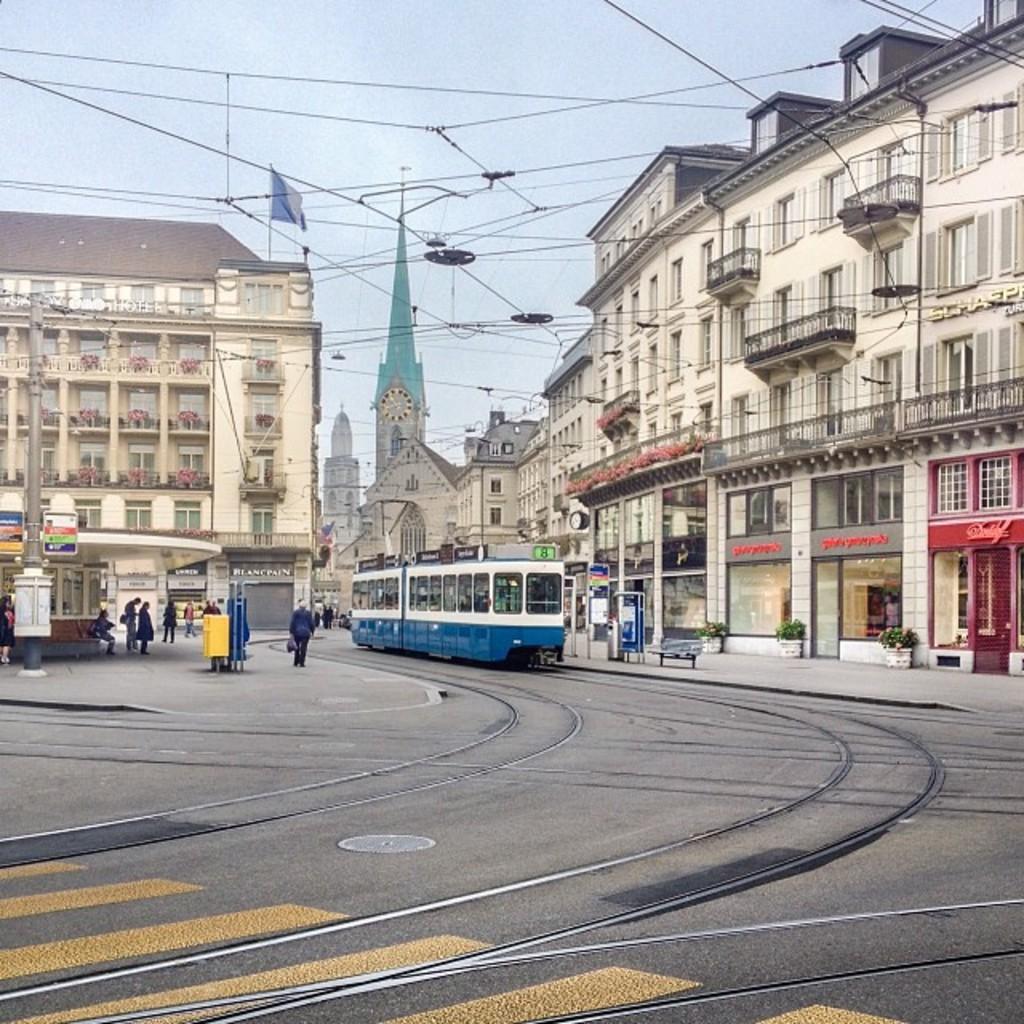Describe this image in one or two sentences. In this image, we can see a train on the track. There are some buildings and wires in the middle of the image. There is a sky at the top of the image. 